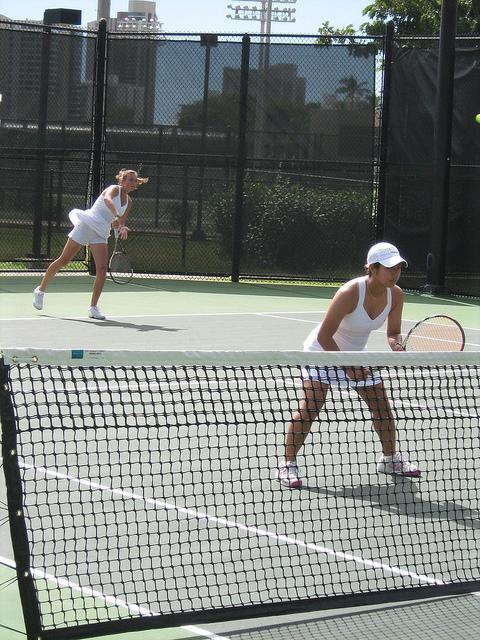How many people are visible?
Give a very brief answer. 2. How many blue airplanes are in the image?
Give a very brief answer. 0. 